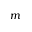Convert formula to latex. <formula><loc_0><loc_0><loc_500><loc_500>m</formula> 